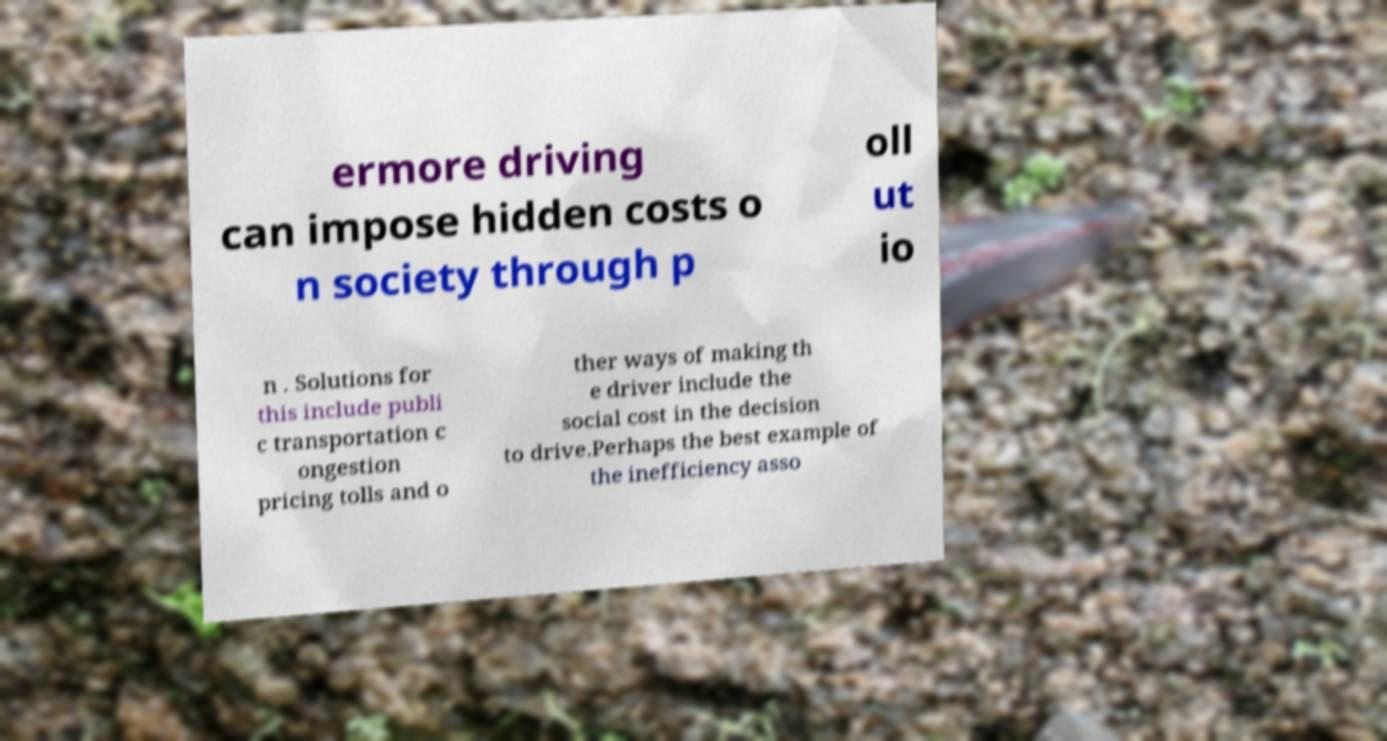Please identify and transcribe the text found in this image. ermore driving can impose hidden costs o n society through p oll ut io n . Solutions for this include publi c transportation c ongestion pricing tolls and o ther ways of making th e driver include the social cost in the decision to drive.Perhaps the best example of the inefficiency asso 